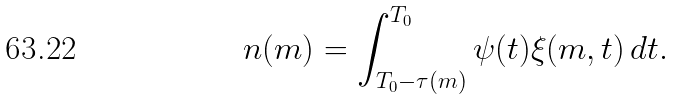Convert formula to latex. <formula><loc_0><loc_0><loc_500><loc_500>n ( m ) = \int _ { T _ { 0 } - \tau ( m ) } ^ { T _ { 0 } } \psi ( t ) \xi ( m , t ) \, d t .</formula> 